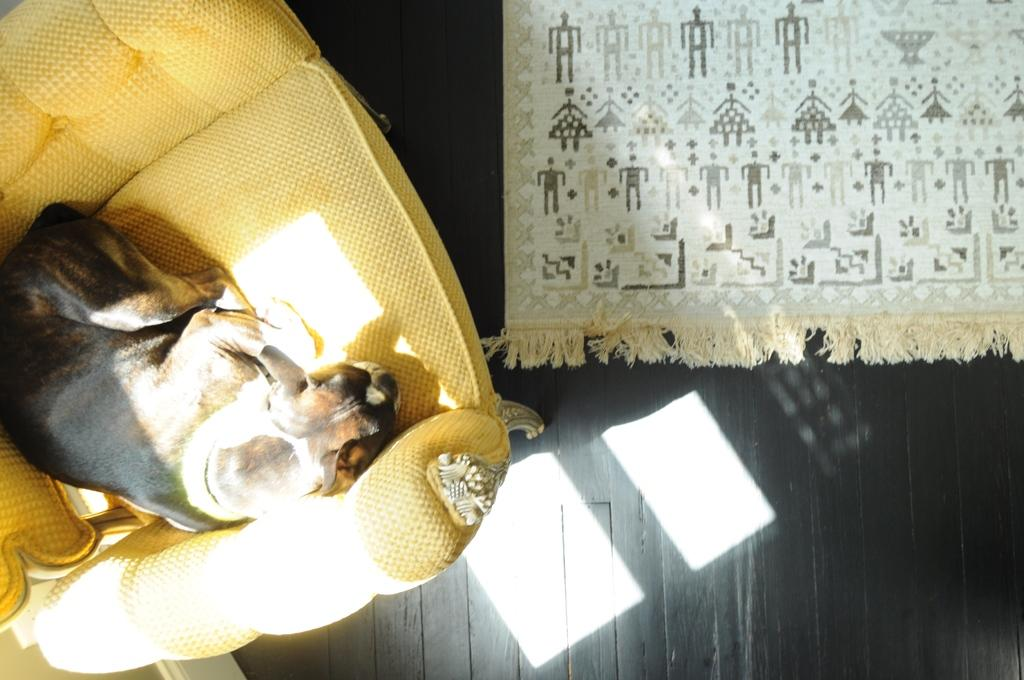What type of animal is sitting on the couch in the image? There is a dog visible on a couch on the left side of the image. What type of flooring is visible on the right side of the image? There is a carpet visible on the right side of the image. What color is the ink spilled on the carpet in the image? There is no ink spilled on the carpet in the image. Is there a basketball game happening in the image? There is no basketball game or any reference to a basketball in the image. 